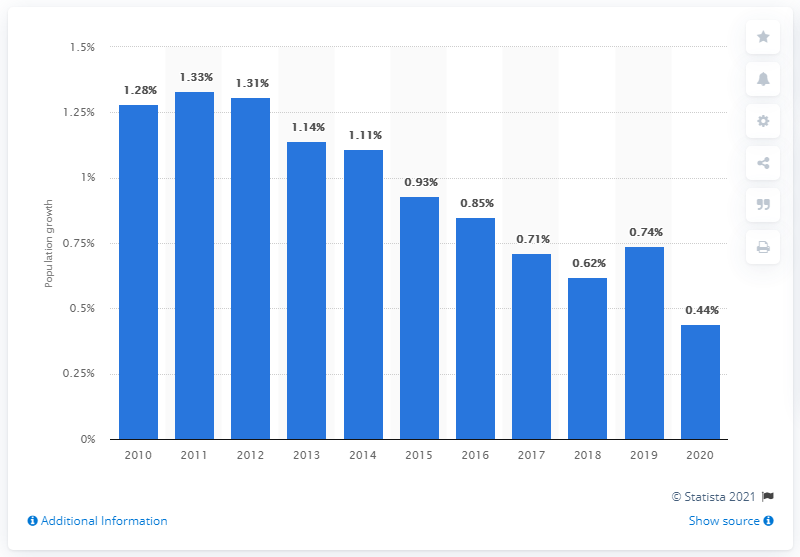Draw attention to some important aspects in this diagram. In 2020, Norway's population growth rate was 0.44. In 2011, Norway's population growth rate was 1.33%. 